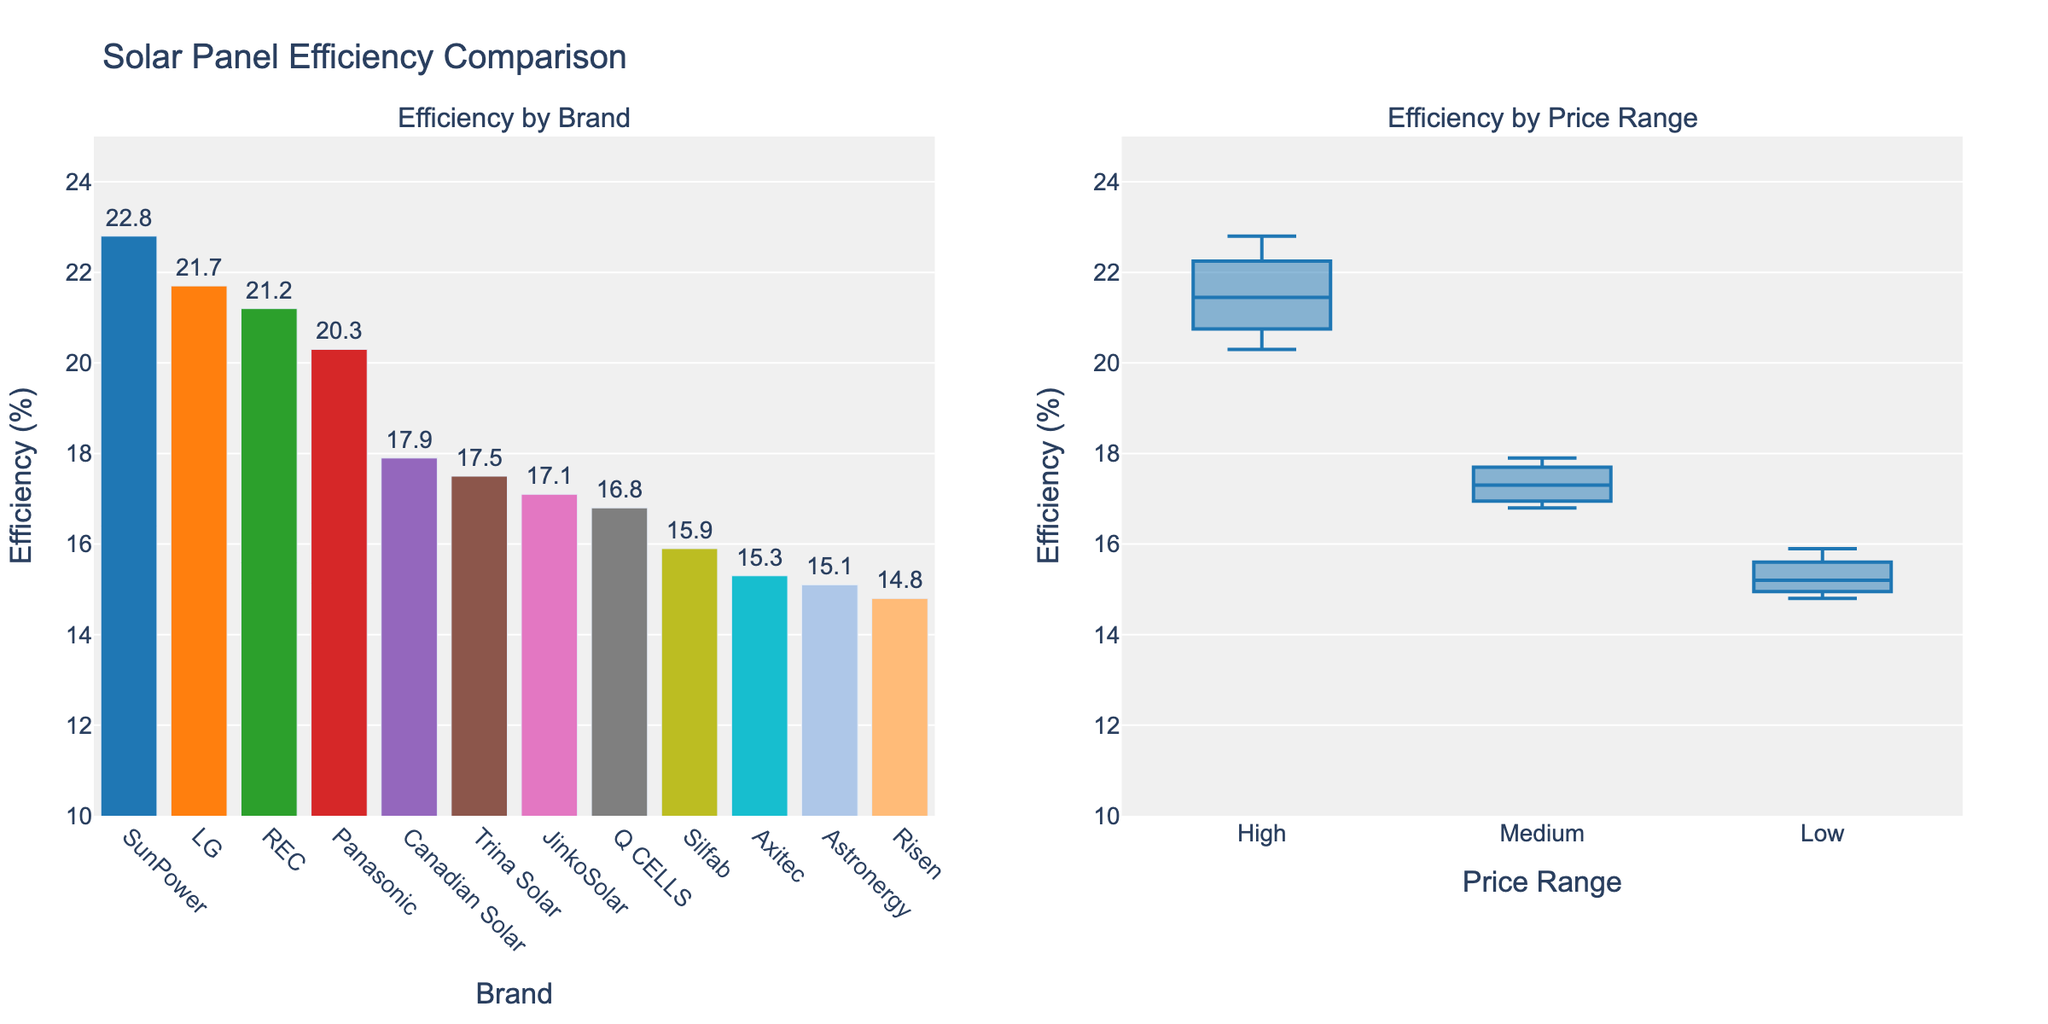What is the highest efficiency among the brands listed? By looking at the bar chart, the highest bar represents SunPower with an efficiency of 22.8%.
Answer: 22.8% How many price ranges are there in the box plot? Observing the X-axis of the box plot on the right, there are three distinct categories: High, Medium, and Low.
Answer: 3 Which brand has the lowest efficiency, and what is its value? According to the bar chart on the left, the lowest bar is for Risen, with an efficiency of 14.8%.
Answer: Risen, 14.8% What is the average efficiency of solar panels in the High price range? In the box plot, listing the High price range efficiencies: SunPower (22.8), LG (21.7), REC (21.2), and Panasonic (20.3). The average is calculated as (22.8 + 21.7 + 21.2 + 20.3) / 4, which equals 21.5%.
Answer: 21.5% Is the efficiency distribution more dispersed in the Medium or Low price range? By comparing the lengths of the box plots for both price ranges, the Medium price range box plot extends more, indicating a higher dispersion.
Answer: Medium Compare the efficiency of Canadian Solar and Trina Solar. Which one is higher and by how much? Checking their respective bars on the bar chart, Canadian Solar has an efficiency of 17.9% while Trina Solar has 17.5%. The difference is 17.9 - 17.5 = 0.4%.
Answer: Canadian Solar, 0.4% What is the median efficiency for solar panels in the Low price range? The box plot for the Low price range displays the median line in the middle, which is at about 15.3%.
Answer: 15.3% Which price range generally has the highest efficiencies? By looking at the distribution of the boxes in the box plot, the High price range has higher efficiency values compared to Medium and Low price ranges.
Answer: High What is the range of efficiencies for the Medium price range? The interquartile range for the Medium price range can be estimated from the box plot's lower and upper quartiles, from around 16.8% to 17.9%, so approximately 1.1%.
Answer: 1.1% How many brands fall under the Low price range? Referring to the box plot and the bar chart, the brands under the Low price range are Silfab, Axitec, Astronergy, and Risen. There are 4 brands in this range.
Answer: 4 